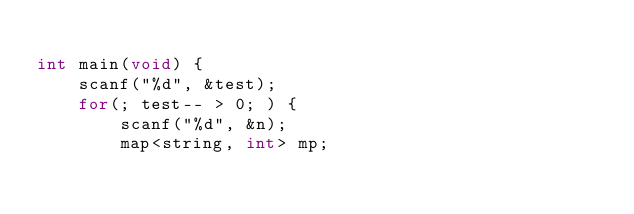Convert code to text. <code><loc_0><loc_0><loc_500><loc_500><_C++_>
int main(void) {
    scanf("%d", &test);
    for(; test-- > 0; ) {
    	scanf("%d", &n);
    	map<string, int> mp;</code> 